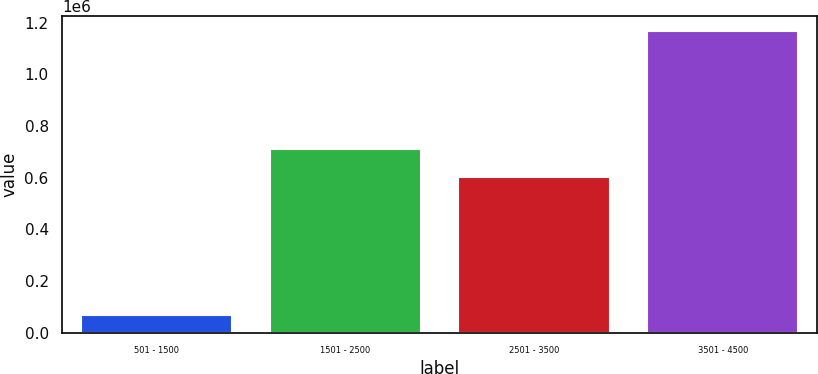Convert chart to OTSL. <chart><loc_0><loc_0><loc_500><loc_500><bar_chart><fcel>501 - 1500<fcel>1501 - 2500<fcel>2501 - 3500<fcel>3501 - 4500<nl><fcel>68653<fcel>712410<fcel>602560<fcel>1.16715e+06<nl></chart> 